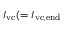<formula> <loc_0><loc_0><loc_500><loc_500>I _ { v c } ( = I _ { v c , e n d }</formula> 